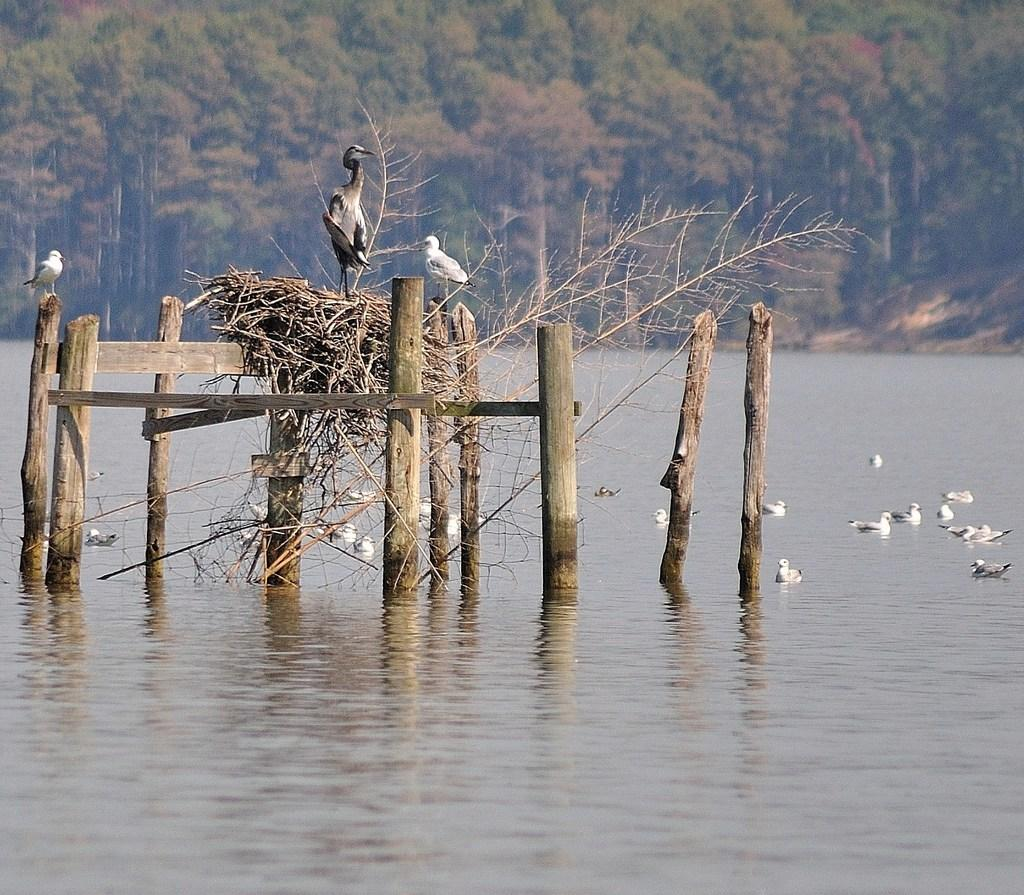What type of animals can be seen in the image? There are many birds in the image. Where are some of the birds located? Some birds are on wooden poles, while others are in the water. What structures can be seen in the image that are associated with the birds? There are nests in the image. What can be seen in the background of the image? There are trees in the background of the image. Can you see any fingers or hands in the image? There are no fingers or hands visible in the image. Is there any plastic material present in the image? There is no plastic material present in the image. 